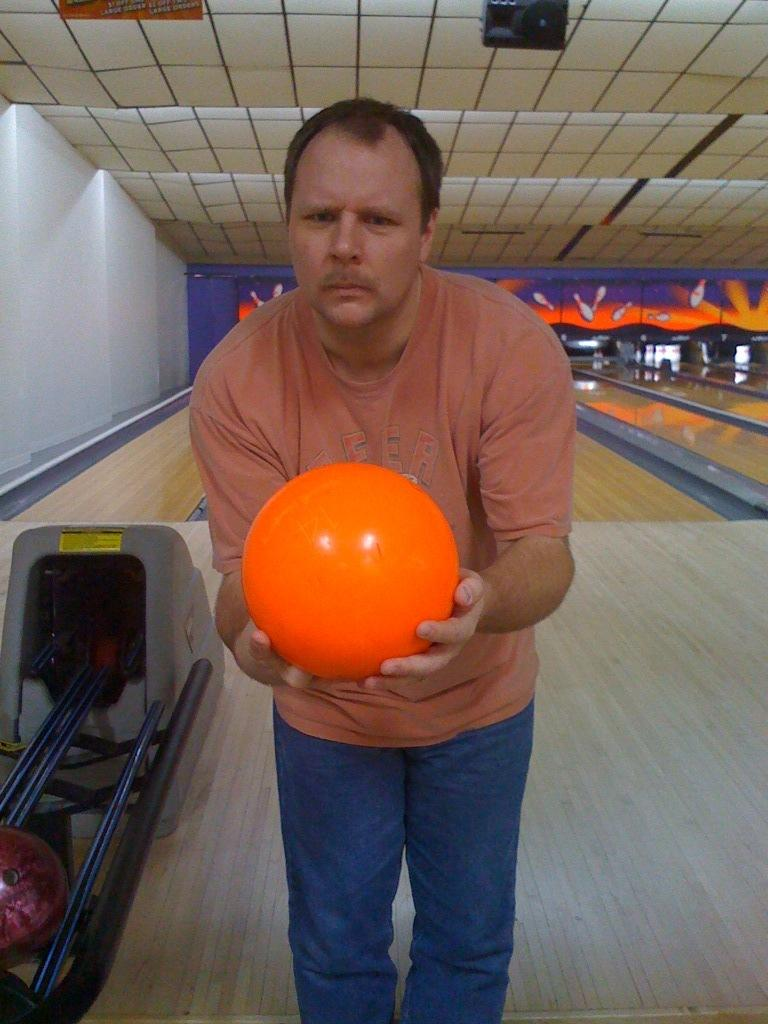What is the main subject of the image? There is a person in the image. What is the person holding in the image? The person is holding a bowling ball. Can you describe the setting or background of the image? The background appears to be a bowling alley or arena. What is the person's temper like in the image? There is no information about the person's temper in the image. 